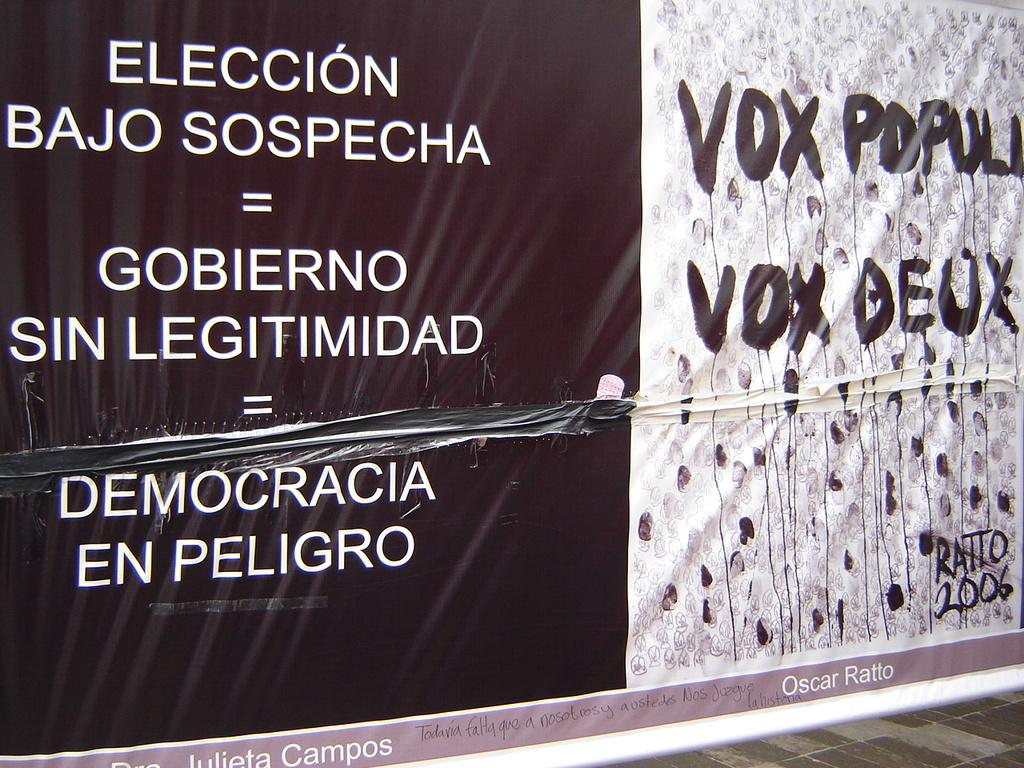<image>
Offer a succinct explanation of the picture presented. sign that is black on left and white on right and has the word vox on it twice 